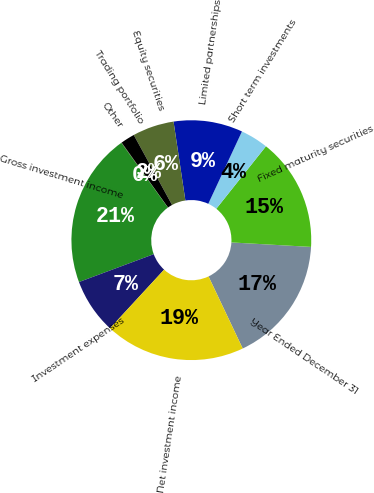Convert chart. <chart><loc_0><loc_0><loc_500><loc_500><pie_chart><fcel>Year Ended December 31<fcel>Fixed maturity securities<fcel>Short term investments<fcel>Limited partnerships<fcel>Equity securities<fcel>Trading portfolio<fcel>Other<fcel>Gross investment income<fcel>Investment expenses<fcel>Net investment income<nl><fcel>17.06%<fcel>15.21%<fcel>3.75%<fcel>9.31%<fcel>5.6%<fcel>1.9%<fcel>0.05%<fcel>20.76%<fcel>7.46%<fcel>18.91%<nl></chart> 